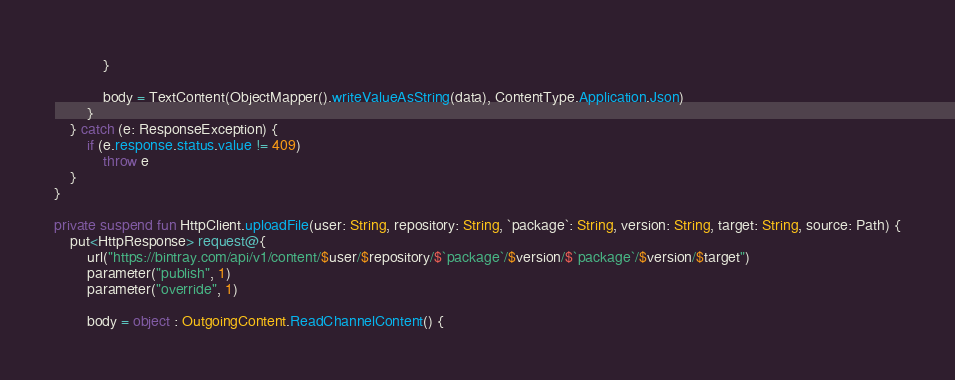<code> <loc_0><loc_0><loc_500><loc_500><_Kotlin_>            }

            body = TextContent(ObjectMapper().writeValueAsString(data), ContentType.Application.Json)
        }
    } catch (e: ResponseException) {
        if (e.response.status.value != 409)
            throw e
    }
}

private suspend fun HttpClient.uploadFile(user: String, repository: String, `package`: String, version: String, target: String, source: Path) {
    put<HttpResponse> request@{
        url("https://bintray.com/api/v1/content/$user/$repository/$`package`/$version/$`package`/$version/$target")
        parameter("publish", 1)
        parameter("override", 1)

        body = object : OutgoingContent.ReadChannelContent() {</code> 